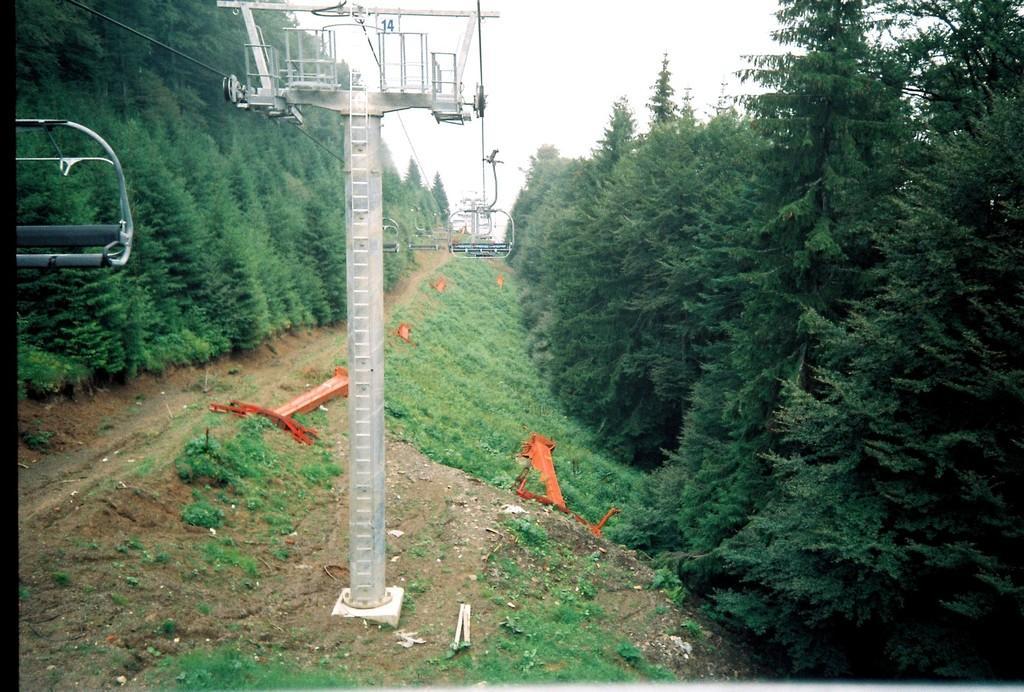Please provide a concise description of this image. This is an outside view. In the middle of the image there are few pillars and cable cars. On the right and left side of the image there are many trees. At the bottom, I can see the grass on the ground. At the top of the image I can see the sky. 